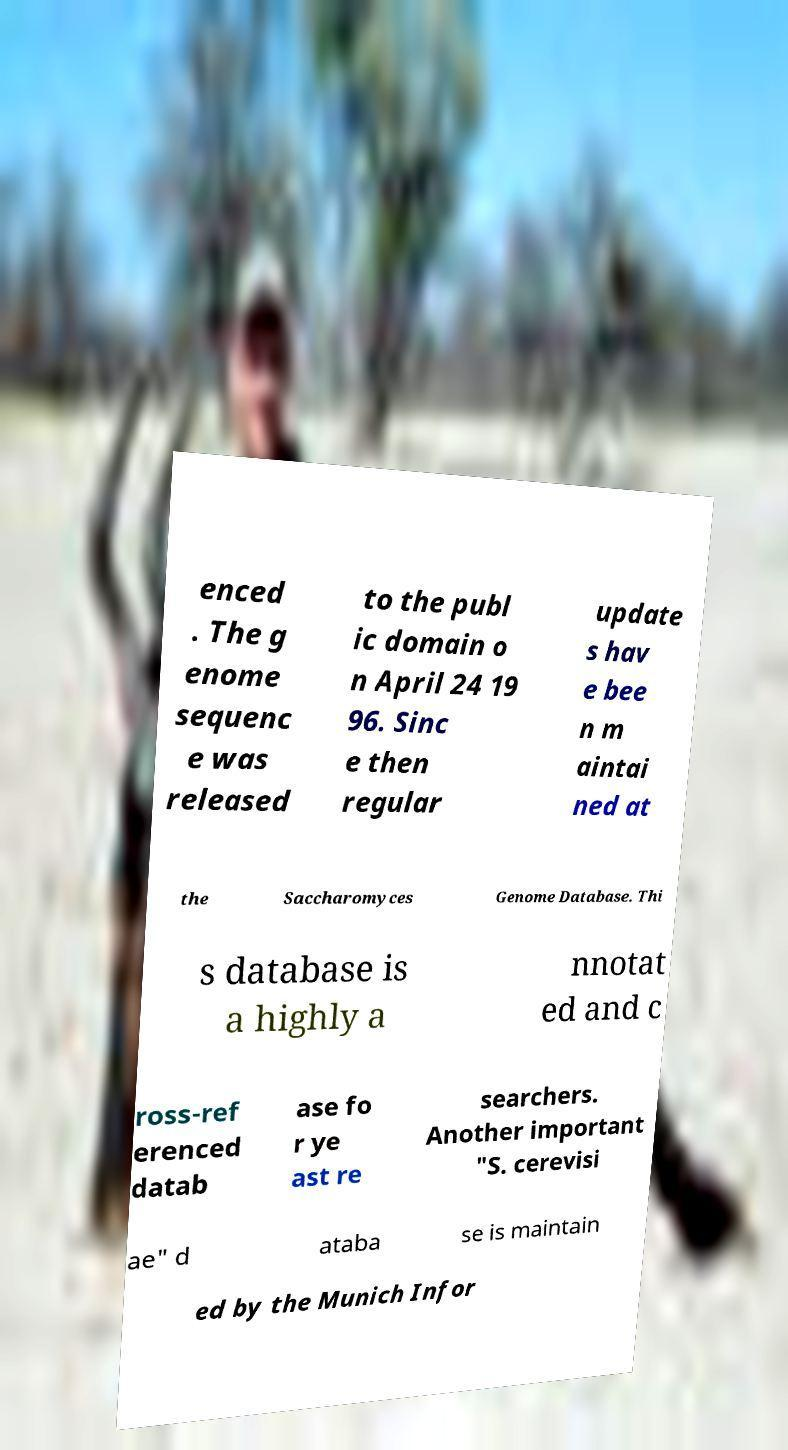I need the written content from this picture converted into text. Can you do that? enced . The g enome sequenc e was released to the publ ic domain o n April 24 19 96. Sinc e then regular update s hav e bee n m aintai ned at the Saccharomyces Genome Database. Thi s database is a highly a nnotat ed and c ross-ref erenced datab ase fo r ye ast re searchers. Another important "S. cerevisi ae" d ataba se is maintain ed by the Munich Infor 